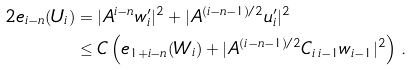<formula> <loc_0><loc_0><loc_500><loc_500>2 e _ { i - n } ( U _ { i } ) & = | A ^ { i - n } w _ { i } ^ { \prime } | ^ { 2 } + | A ^ { ( i - n - 1 ) / 2 } u _ { i } ^ { \prime } | ^ { 2 } \\ & \leq C \left ( e _ { 1 + i - n } ( W _ { i } ) + | A ^ { ( i - n - 1 ) / 2 } C _ { i \, i - 1 } w _ { i - 1 } | ^ { 2 } \right ) \, .</formula> 